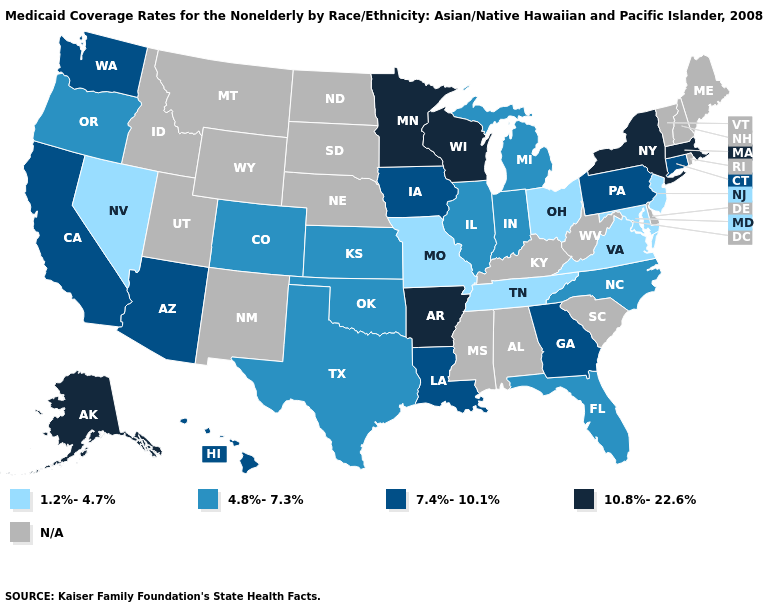What is the lowest value in the USA?
Keep it brief. 1.2%-4.7%. Does Texas have the lowest value in the USA?
Keep it brief. No. What is the lowest value in the USA?
Concise answer only. 1.2%-4.7%. Does the first symbol in the legend represent the smallest category?
Concise answer only. Yes. Name the states that have a value in the range 10.8%-22.6%?
Answer briefly. Alaska, Arkansas, Massachusetts, Minnesota, New York, Wisconsin. What is the lowest value in states that border Missouri?
Concise answer only. 1.2%-4.7%. What is the value of Oklahoma?
Keep it brief. 4.8%-7.3%. Does Alaska have the highest value in the USA?
Be succinct. Yes. What is the lowest value in the South?
Short answer required. 1.2%-4.7%. Name the states that have a value in the range 4.8%-7.3%?
Write a very short answer. Colorado, Florida, Illinois, Indiana, Kansas, Michigan, North Carolina, Oklahoma, Oregon, Texas. What is the lowest value in the USA?
Keep it brief. 1.2%-4.7%. What is the highest value in states that border Maryland?
Give a very brief answer. 7.4%-10.1%. Name the states that have a value in the range 1.2%-4.7%?
Concise answer only. Maryland, Missouri, Nevada, New Jersey, Ohio, Tennessee, Virginia. What is the value of Louisiana?
Write a very short answer. 7.4%-10.1%. Which states have the lowest value in the USA?
Be succinct. Maryland, Missouri, Nevada, New Jersey, Ohio, Tennessee, Virginia. 